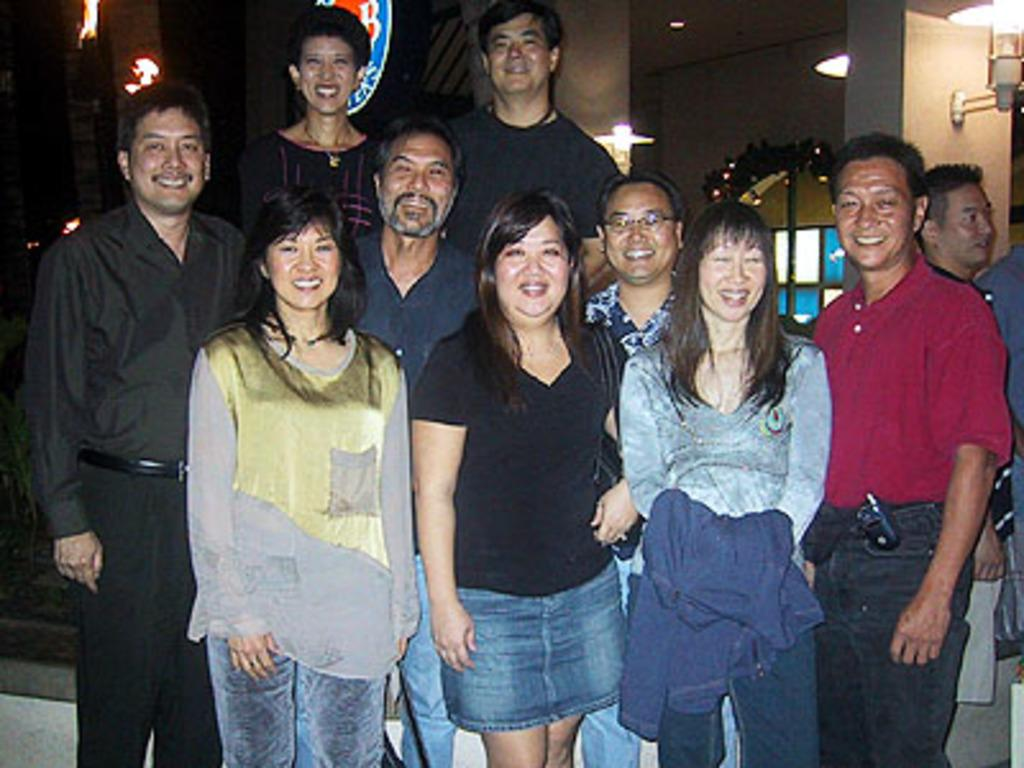What are the people in the image doing? The persons standing in the image are smiling. What can be seen in the background of the image? There are walls, windows, doors, and electric lights in the background of the image. How many elements can be identified in the background of the image? There are four elements present in the background: walls, windows, doors, and electric lights. What type of grape is being used as a timepiece in the image? There is no grape present in the image, and therefore it cannot be used as a timepiece. 